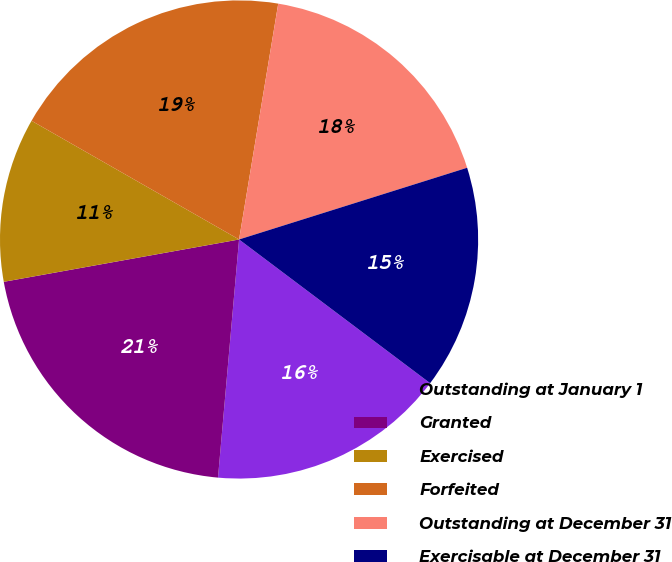Convert chart to OTSL. <chart><loc_0><loc_0><loc_500><loc_500><pie_chart><fcel>Outstanding at January 1<fcel>Granted<fcel>Exercised<fcel>Forfeited<fcel>Outstanding at December 31<fcel>Exercisable at December 31<nl><fcel>16.14%<fcel>20.76%<fcel>11.1%<fcel>19.35%<fcel>17.53%<fcel>15.11%<nl></chart> 